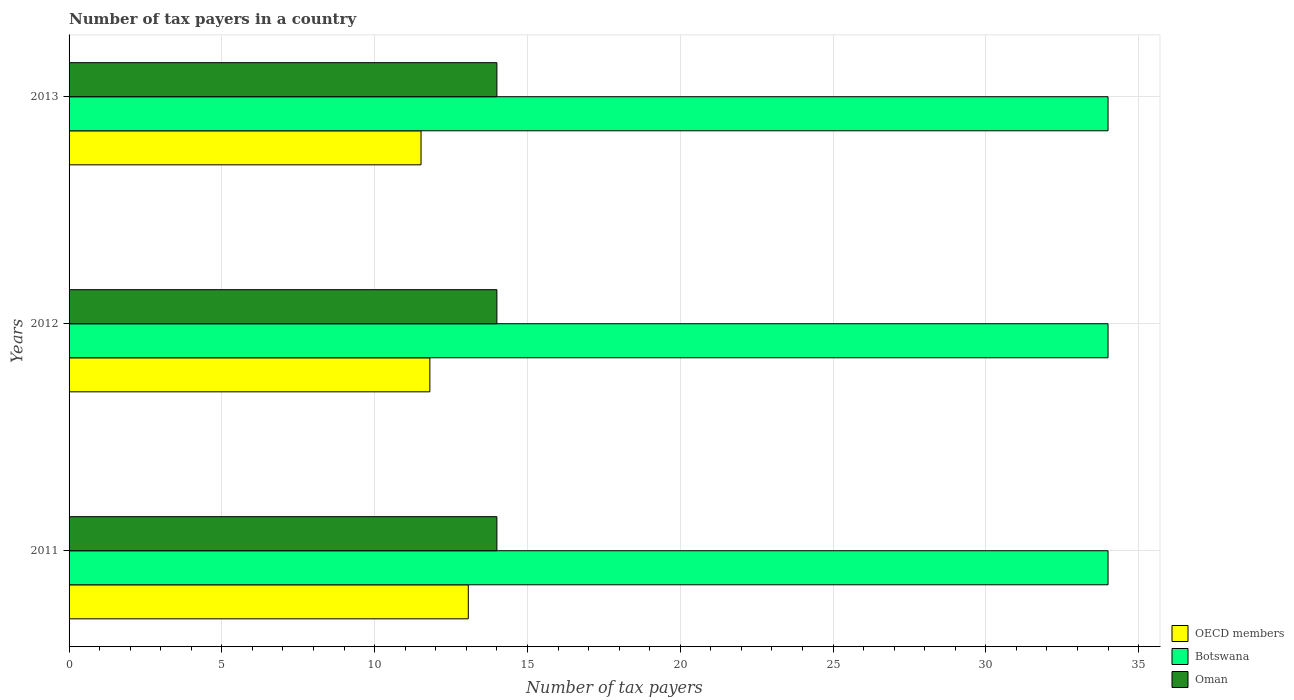Are the number of bars per tick equal to the number of legend labels?
Give a very brief answer. Yes. Are the number of bars on each tick of the Y-axis equal?
Provide a short and direct response. Yes. How many bars are there on the 2nd tick from the top?
Offer a very short reply. 3. How many bars are there on the 3rd tick from the bottom?
Make the answer very short. 3. What is the label of the 1st group of bars from the top?
Provide a short and direct response. 2013. What is the number of tax payers in in OECD members in 2012?
Provide a succinct answer. 11.81. Across all years, what is the maximum number of tax payers in in OECD members?
Your answer should be compact. 13.06. Across all years, what is the minimum number of tax payers in in Botswana?
Keep it short and to the point. 34. In which year was the number of tax payers in in OECD members minimum?
Make the answer very short. 2013. What is the total number of tax payers in in Botswana in the graph?
Make the answer very short. 102. What is the difference between the number of tax payers in in Botswana in 2011 and the number of tax payers in in OECD members in 2012?
Keep it short and to the point. 22.19. What is the average number of tax payers in in OECD members per year?
Provide a succinct answer. 12.13. In the year 2012, what is the difference between the number of tax payers in in OECD members and number of tax payers in in Botswana?
Ensure brevity in your answer.  -22.19. What is the difference between the highest and the second highest number of tax payers in in OECD members?
Offer a very short reply. 1.26. What does the 2nd bar from the top in 2013 represents?
Give a very brief answer. Botswana. What does the 3rd bar from the bottom in 2012 represents?
Ensure brevity in your answer.  Oman. Is it the case that in every year, the sum of the number of tax payers in in Oman and number of tax payers in in Botswana is greater than the number of tax payers in in OECD members?
Keep it short and to the point. Yes. How many bars are there?
Your answer should be very brief. 9. How many years are there in the graph?
Offer a terse response. 3. Does the graph contain grids?
Keep it short and to the point. Yes. How many legend labels are there?
Your answer should be compact. 3. How are the legend labels stacked?
Provide a succinct answer. Vertical. What is the title of the graph?
Provide a succinct answer. Number of tax payers in a country. Does "Canada" appear as one of the legend labels in the graph?
Ensure brevity in your answer.  No. What is the label or title of the X-axis?
Offer a very short reply. Number of tax payers. What is the Number of tax payers in OECD members in 2011?
Provide a short and direct response. 13.06. What is the Number of tax payers in Oman in 2011?
Give a very brief answer. 14. What is the Number of tax payers in OECD members in 2012?
Provide a short and direct response. 11.81. What is the Number of tax payers of OECD members in 2013?
Your response must be concise. 11.52. What is the Number of tax payers in Oman in 2013?
Make the answer very short. 14. Across all years, what is the maximum Number of tax payers in OECD members?
Keep it short and to the point. 13.06. Across all years, what is the minimum Number of tax payers in OECD members?
Offer a very short reply. 11.52. Across all years, what is the minimum Number of tax payers in Botswana?
Provide a short and direct response. 34. What is the total Number of tax payers of OECD members in the graph?
Your answer should be compact. 36.39. What is the total Number of tax payers of Botswana in the graph?
Offer a terse response. 102. What is the total Number of tax payers in Oman in the graph?
Make the answer very short. 42. What is the difference between the Number of tax payers of OECD members in 2011 and that in 2012?
Ensure brevity in your answer.  1.26. What is the difference between the Number of tax payers in Botswana in 2011 and that in 2012?
Your answer should be compact. 0. What is the difference between the Number of tax payers of OECD members in 2011 and that in 2013?
Your answer should be very brief. 1.55. What is the difference between the Number of tax payers of OECD members in 2012 and that in 2013?
Keep it short and to the point. 0.29. What is the difference between the Number of tax payers in Botswana in 2012 and that in 2013?
Provide a succinct answer. 0. What is the difference between the Number of tax payers of Oman in 2012 and that in 2013?
Your answer should be compact. 0. What is the difference between the Number of tax payers of OECD members in 2011 and the Number of tax payers of Botswana in 2012?
Give a very brief answer. -20.94. What is the difference between the Number of tax payers in OECD members in 2011 and the Number of tax payers in Oman in 2012?
Offer a very short reply. -0.94. What is the difference between the Number of tax payers of Botswana in 2011 and the Number of tax payers of Oman in 2012?
Ensure brevity in your answer.  20. What is the difference between the Number of tax payers in OECD members in 2011 and the Number of tax payers in Botswana in 2013?
Your answer should be very brief. -20.94. What is the difference between the Number of tax payers in OECD members in 2011 and the Number of tax payers in Oman in 2013?
Give a very brief answer. -0.94. What is the difference between the Number of tax payers in OECD members in 2012 and the Number of tax payers in Botswana in 2013?
Keep it short and to the point. -22.19. What is the difference between the Number of tax payers in OECD members in 2012 and the Number of tax payers in Oman in 2013?
Offer a very short reply. -2.19. What is the difference between the Number of tax payers of Botswana in 2012 and the Number of tax payers of Oman in 2013?
Provide a succinct answer. 20. What is the average Number of tax payers of OECD members per year?
Offer a terse response. 12.13. What is the average Number of tax payers in Botswana per year?
Offer a terse response. 34. In the year 2011, what is the difference between the Number of tax payers in OECD members and Number of tax payers in Botswana?
Your answer should be compact. -20.94. In the year 2011, what is the difference between the Number of tax payers in OECD members and Number of tax payers in Oman?
Make the answer very short. -0.94. In the year 2012, what is the difference between the Number of tax payers in OECD members and Number of tax payers in Botswana?
Give a very brief answer. -22.19. In the year 2012, what is the difference between the Number of tax payers in OECD members and Number of tax payers in Oman?
Offer a very short reply. -2.19. In the year 2013, what is the difference between the Number of tax payers of OECD members and Number of tax payers of Botswana?
Keep it short and to the point. -22.48. In the year 2013, what is the difference between the Number of tax payers in OECD members and Number of tax payers in Oman?
Offer a terse response. -2.48. In the year 2013, what is the difference between the Number of tax payers in Botswana and Number of tax payers in Oman?
Provide a short and direct response. 20. What is the ratio of the Number of tax payers of OECD members in 2011 to that in 2012?
Provide a succinct answer. 1.11. What is the ratio of the Number of tax payers of Botswana in 2011 to that in 2012?
Your answer should be compact. 1. What is the ratio of the Number of tax payers of Oman in 2011 to that in 2012?
Offer a terse response. 1. What is the ratio of the Number of tax payers in OECD members in 2011 to that in 2013?
Keep it short and to the point. 1.13. What is the ratio of the Number of tax payers of Botswana in 2011 to that in 2013?
Your answer should be compact. 1. What is the ratio of the Number of tax payers in OECD members in 2012 to that in 2013?
Give a very brief answer. 1.03. What is the ratio of the Number of tax payers in Botswana in 2012 to that in 2013?
Keep it short and to the point. 1. What is the difference between the highest and the second highest Number of tax payers of OECD members?
Make the answer very short. 1.26. What is the difference between the highest and the lowest Number of tax payers in OECD members?
Your answer should be very brief. 1.55. What is the difference between the highest and the lowest Number of tax payers in Oman?
Your response must be concise. 0. 